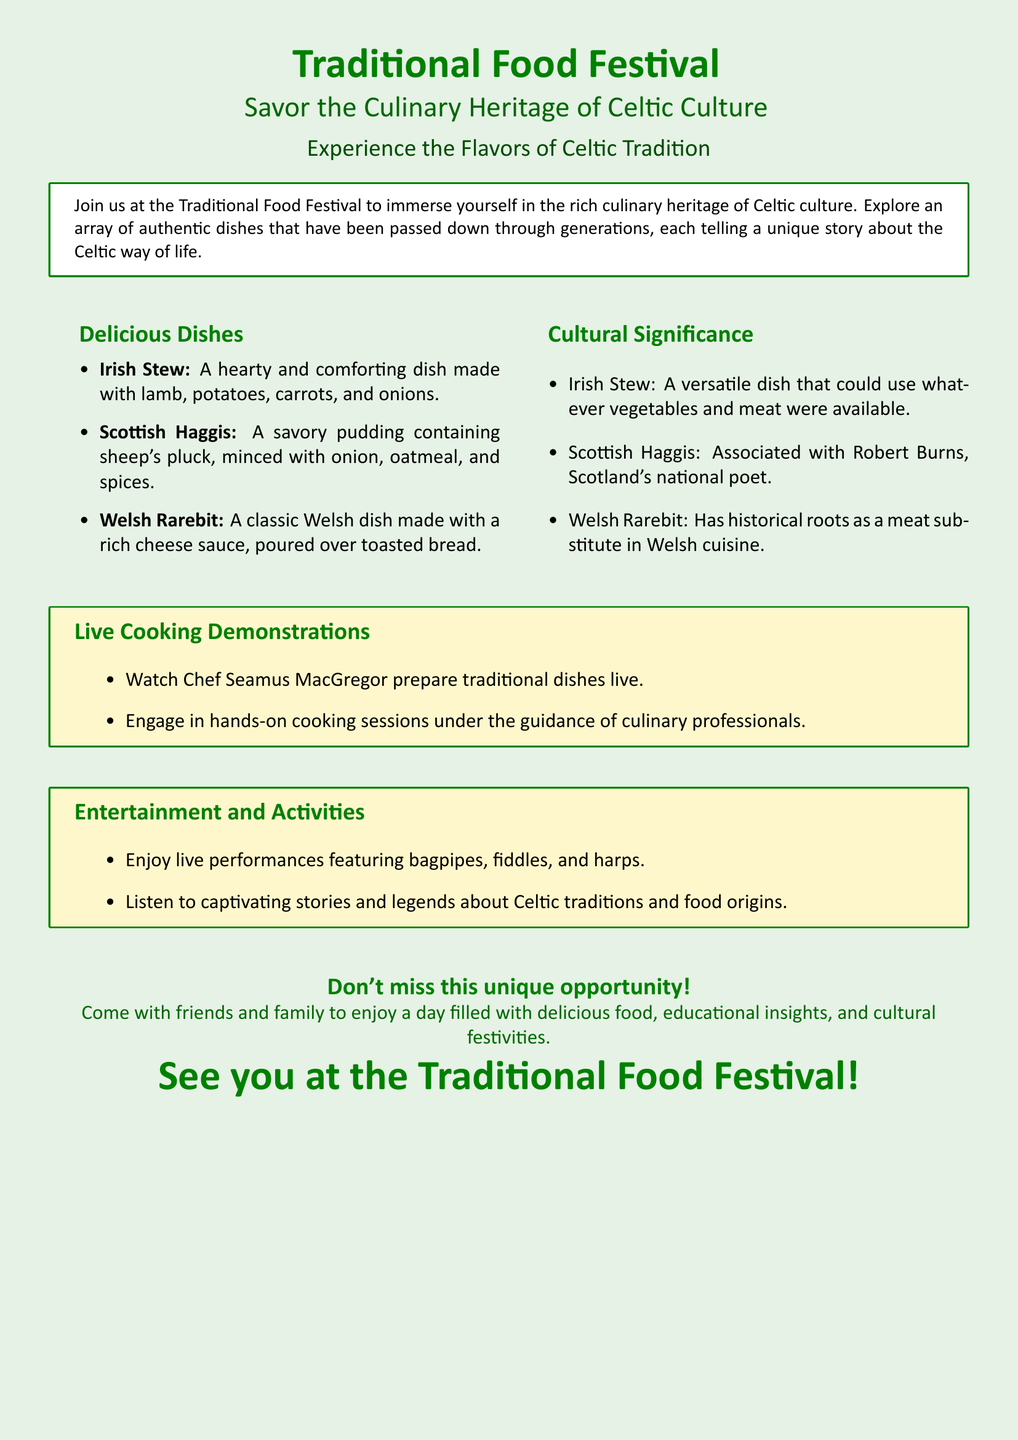What is the name of the event? The event is called "Traditional Food Festival."
Answer: Traditional Food Festival What culture is highlighted in the festival? The advertisement emphasizes Celtic culture.
Answer: Celtic culture How many delicious dishes are mentioned? There are three delicious dishes listed in the document.
Answer: 3 Who is the chef for the live cooking demonstrations? The chef mentioned for the demonstrations is Chef Seamus MacGregor.
Answer: Chef Seamus MacGregor What dish is associated with Robert Burns? The dish linked to Robert Burns is Scottish Haggis.
Answer: Scottish Haggis What type of live performances will be featured? The performances will include bagpipes, fiddles, and harps.
Answer: bagpipes, fiddles, and harps What is the significance of Irish Stew in the context provided? Irish Stew is described as a versatile dish using available ingredients.
Answer: A versatile dish What type of activity is included under "Entertainment and Activities"? The document mentions listening to stories and legends about Celtic traditions.
Answer: Listening to stories and legends How is the slogan encouraging attendance phrased? The slogan encourages coming with friends and family for a day filled with food and festivities.
Answer: Come with friends and family 